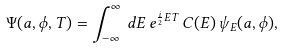<formula> <loc_0><loc_0><loc_500><loc_500>\Psi ( a , \phi , T ) = \int _ { - \infty } ^ { \infty } \, d E \, e ^ { \frac { i } { 2 } E T } \, C ( E ) \, \psi _ { E } ( a , \phi ) ,</formula> 